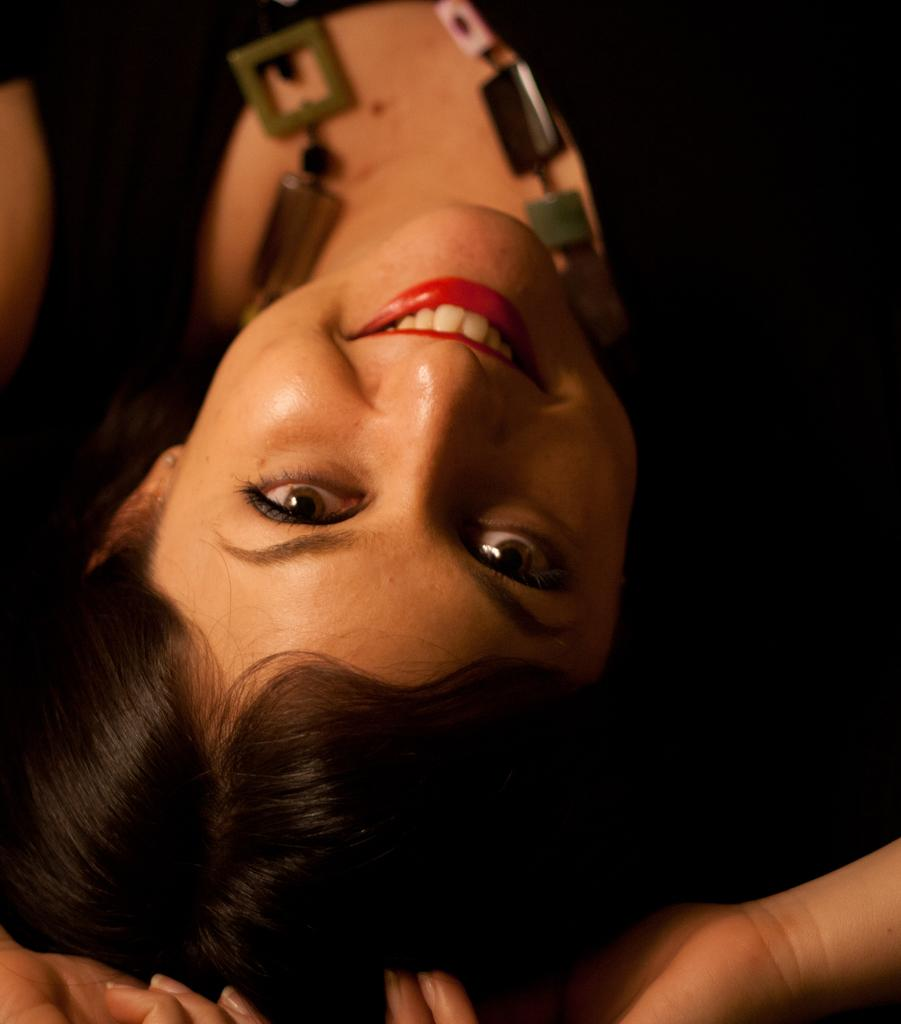Who is present in the image? There is a woman in the image. What is the woman's facial expression? The woman is smiling. What accessory is the woman wearing? The woman is wearing a necklace. What can be observed about the background of the image? The background of the image is dark. What type of wound can be seen on the woman's arm in the image? There is no wound visible on the woman's arm in the image. What kind of needle is being used by the woman in the image? There is no needle present in the image. 